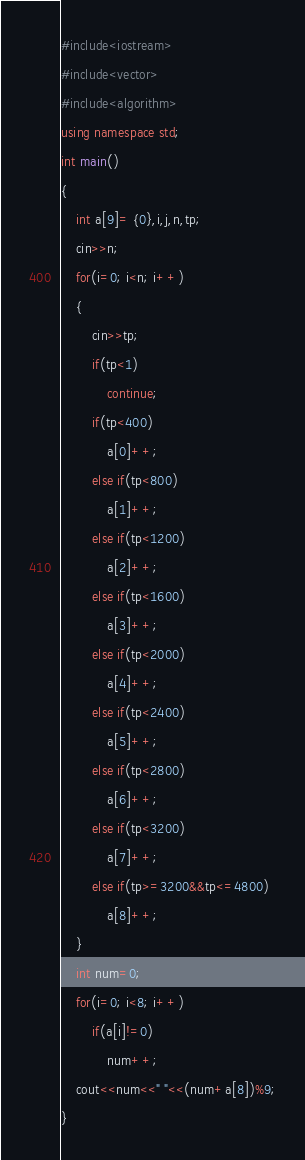Convert code to text. <code><loc_0><loc_0><loc_500><loc_500><_C++_>#include<iostream>
#include<vector>
#include<algorithm>
using namespace std;
int main()
{
    int a[9]= {0},i,j,n,tp;
    cin>>n;
    for(i=0; i<n; i++)
    {
        cin>>tp;
        if(tp<1)
            continue;
        if(tp<400)
            a[0]++;
        else if(tp<800)
            a[1]++;
        else if(tp<1200)
            a[2]++;
        else if(tp<1600)
            a[3]++;
        else if(tp<2000)
            a[4]++;
        else if(tp<2400)
            a[5]++;
        else if(tp<2800)
            a[6]++;
        else if(tp<3200)
            a[7]++;
        else if(tp>=3200&&tp<=4800)
            a[8]++;
    }
    int num=0;
    for(i=0; i<8; i++)
        if(a[i]!=0)
            num++;
    cout<<num<<" "<<(num+a[8])%9;
}
</code> 